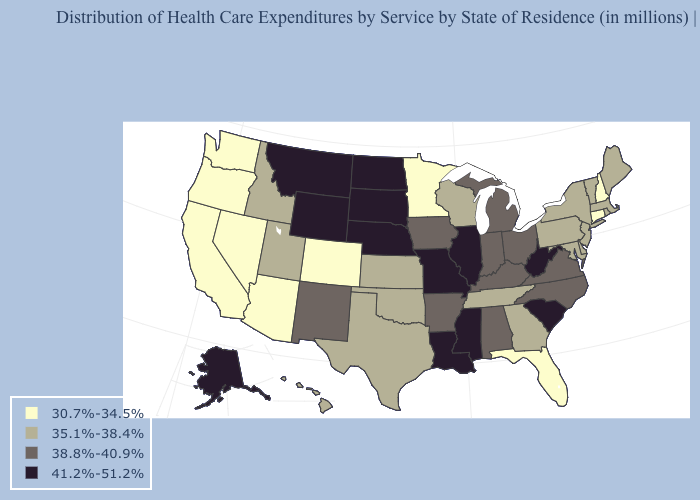Among the states that border Washington , does Oregon have the highest value?
Quick response, please. No. What is the value of Missouri?
Short answer required. 41.2%-51.2%. Which states have the lowest value in the West?
Quick response, please. Arizona, California, Colorado, Nevada, Oregon, Washington. What is the value of Indiana?
Quick response, please. 38.8%-40.9%. What is the lowest value in the West?
Keep it brief. 30.7%-34.5%. Does Michigan have the same value as North Dakota?
Write a very short answer. No. Does Maine have the same value as Vermont?
Be succinct. Yes. Does Delaware have the same value as Texas?
Concise answer only. Yes. Does North Dakota have the lowest value in the MidWest?
Give a very brief answer. No. Name the states that have a value in the range 35.1%-38.4%?
Write a very short answer. Delaware, Georgia, Hawaii, Idaho, Kansas, Maine, Maryland, Massachusetts, New Jersey, New York, Oklahoma, Pennsylvania, Rhode Island, Tennessee, Texas, Utah, Vermont, Wisconsin. Name the states that have a value in the range 30.7%-34.5%?
Be succinct. Arizona, California, Colorado, Connecticut, Florida, Minnesota, Nevada, New Hampshire, Oregon, Washington. What is the highest value in the West ?
Short answer required. 41.2%-51.2%. Does Wyoming have the highest value in the West?
Answer briefly. Yes. What is the value of Vermont?
Short answer required. 35.1%-38.4%. 